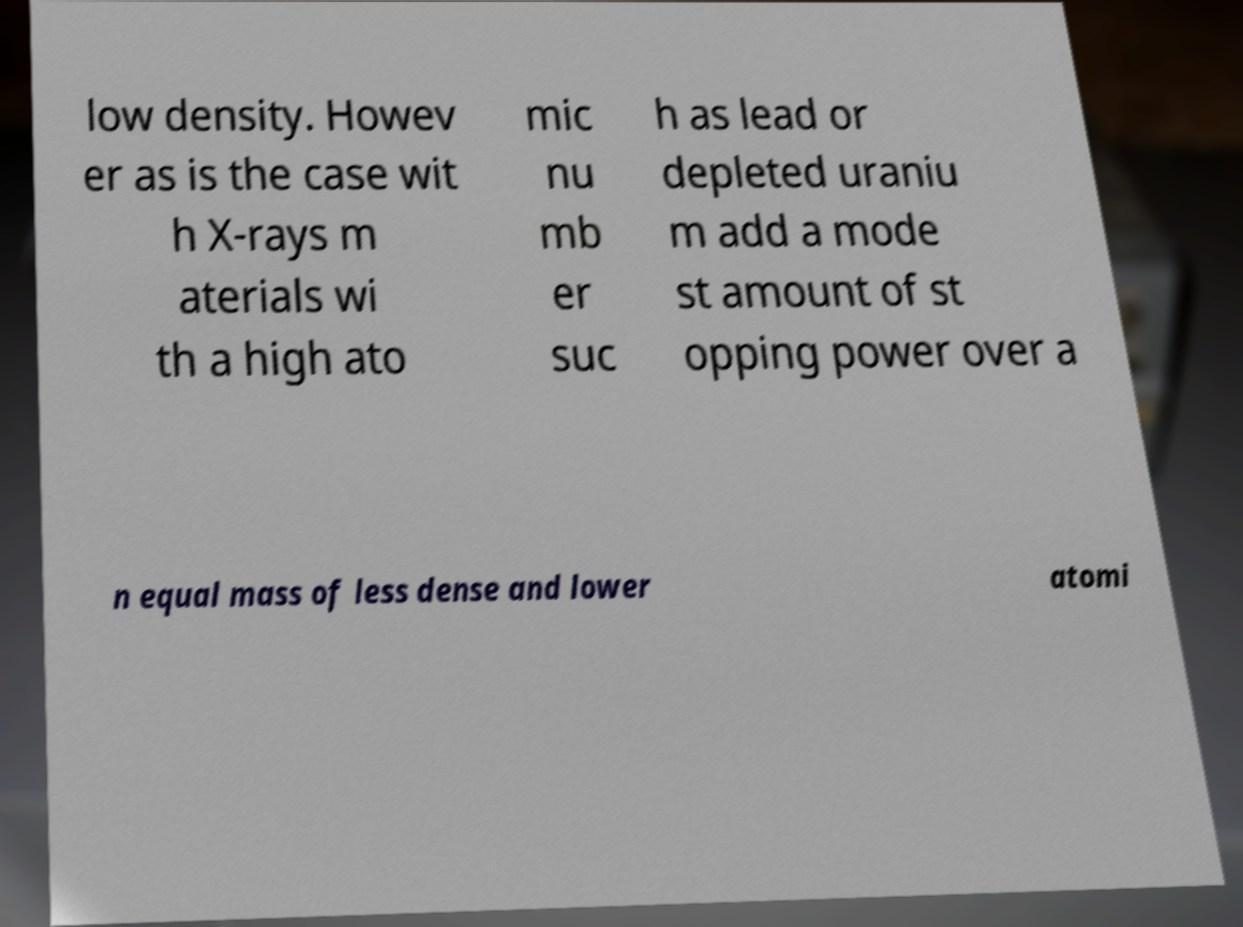Can you read and provide the text displayed in the image?This photo seems to have some interesting text. Can you extract and type it out for me? low density. Howev er as is the case wit h X-rays m aterials wi th a high ato mic nu mb er suc h as lead or depleted uraniu m add a mode st amount of st opping power over a n equal mass of less dense and lower atomi 